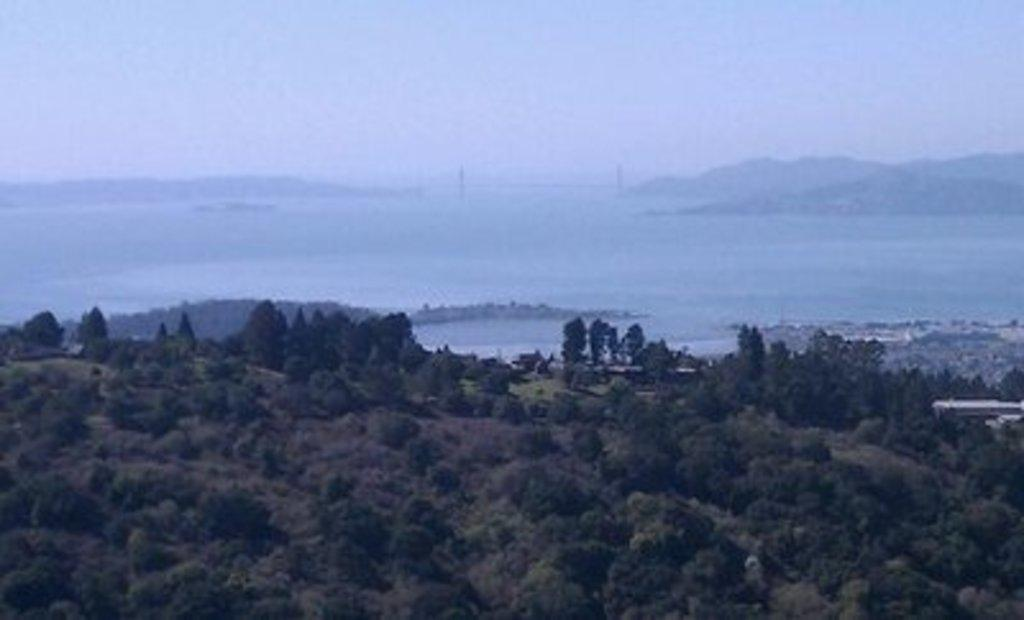What type of vegetation can be seen in the image? There are trees in the image. What natural element is visible in the image? There is water visible in the image. What geographical features can be seen in the background of the image? There are hills in the background of the image. What is visible in the sky in the image? The sky is visible in the background of the image. What is the tendency of the cattle in the image? There are no cattle present in the image. How does the water twist in the image? The water does not twist in the image; it appears to be still or flowing in a straight line. 